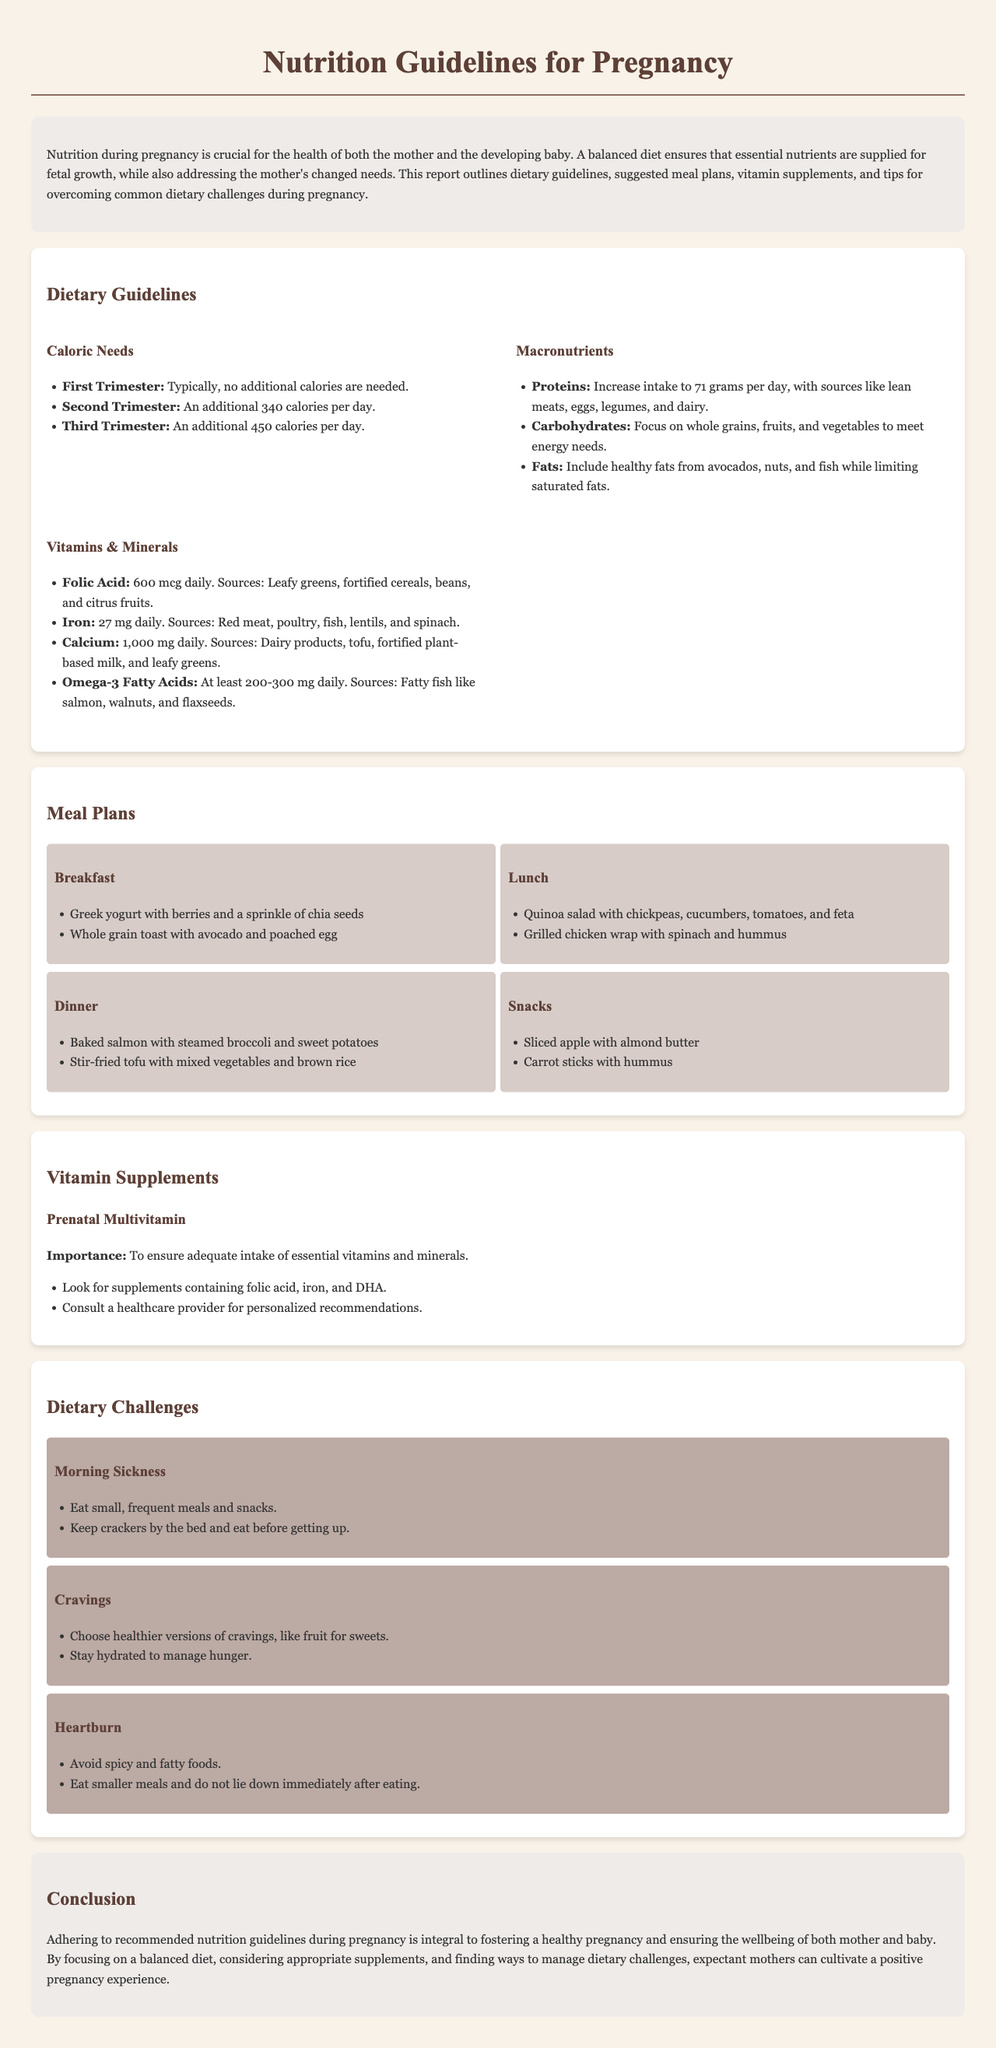What are the caloric needs during the second trimester? The second trimester requires an additional 340 calories per day as stated in the dietary guidelines.
Answer: 340 calories What is the daily requirement for folic acid? The report specifies that the daily requirement for folic acid is 600 mcg.
Answer: 600 mcg Name two sources of healthy fats recommended in the guidelines. The guidelines suggest including healthy fats from avocados and nuts, among others.
Answer: Avocados, nuts What is a suitable breakfast option mentioned in the meal plans? One breakfast option in the meal plans is Greek yogurt with berries and a sprinkle of chia seeds.
Answer: Greek yogurt with berries How much iron is recommended daily during pregnancy? The report indicates that 27 mg of iron is recommended daily during pregnancy.
Answer: 27 mg What should be avoided to manage heartburn according to the dietary challenges section? The dietary challenges section recommends avoiding spicy and fatty foods.
Answer: Spicy and fatty foods What dietary suggestion is given for managing morning sickness? One suggestion for managing morning sickness is to eat small, frequent meals and snacks.
Answer: Small, frequent meals What should a prenatal multivitamin contain? The report emphasizes that a prenatal multivitamin should contain folic acid, iron, and DHA.
Answer: Folic acid, iron, and DHA 